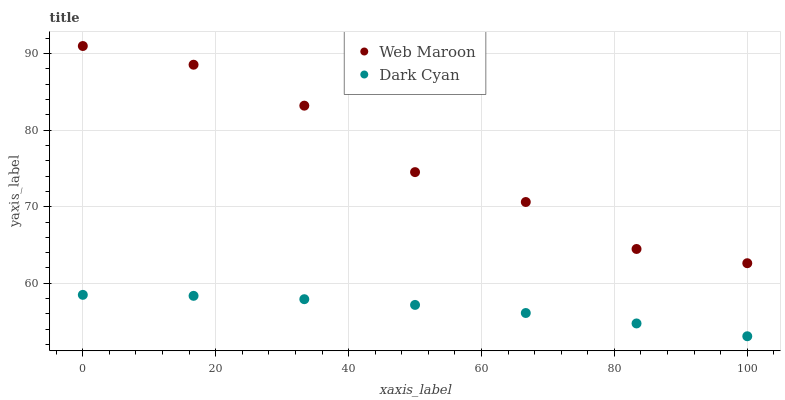Does Dark Cyan have the minimum area under the curve?
Answer yes or no. Yes. Does Web Maroon have the maximum area under the curve?
Answer yes or no. Yes. Does Web Maroon have the minimum area under the curve?
Answer yes or no. No. Is Dark Cyan the smoothest?
Answer yes or no. Yes. Is Web Maroon the roughest?
Answer yes or no. Yes. Is Web Maroon the smoothest?
Answer yes or no. No. Does Dark Cyan have the lowest value?
Answer yes or no. Yes. Does Web Maroon have the lowest value?
Answer yes or no. No. Does Web Maroon have the highest value?
Answer yes or no. Yes. Is Dark Cyan less than Web Maroon?
Answer yes or no. Yes. Is Web Maroon greater than Dark Cyan?
Answer yes or no. Yes. Does Dark Cyan intersect Web Maroon?
Answer yes or no. No. 